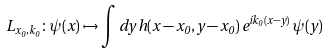Convert formula to latex. <formula><loc_0><loc_0><loc_500><loc_500>L _ { x _ { 0 } , k _ { 0 } } \colon \psi ( x ) \mapsto \int d y \, h ( x - x _ { 0 } , y - x _ { 0 } ) \, e ^ { i k _ { 0 } ( x - y ) } \, \psi ( y )</formula> 